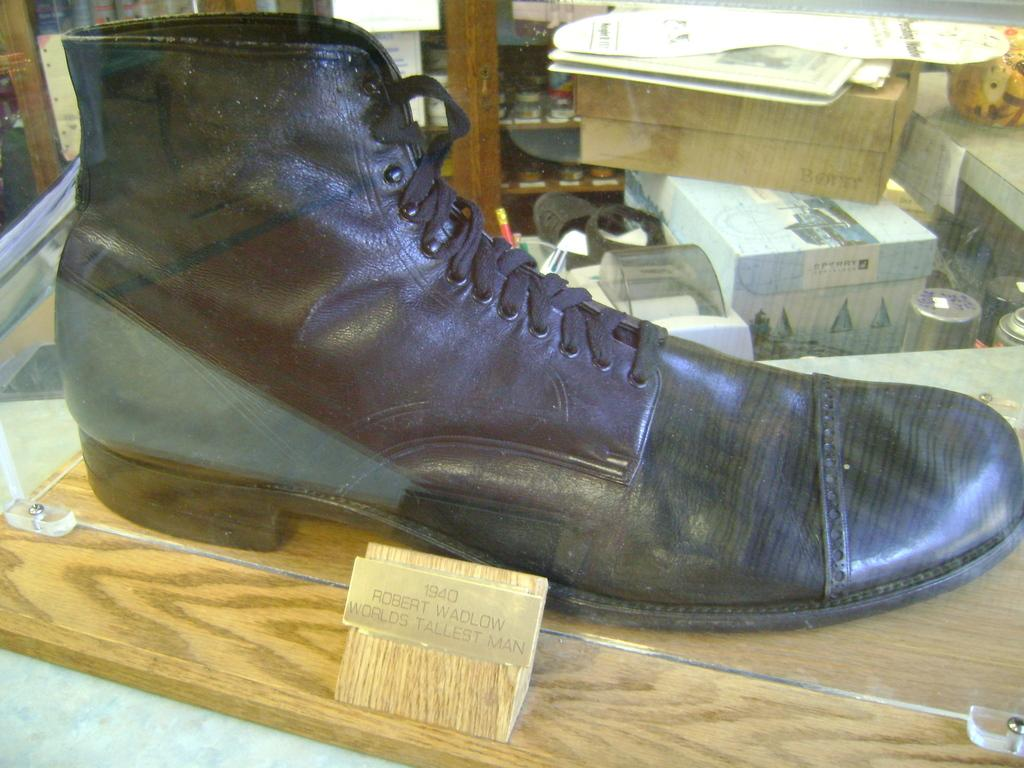What can be found in the image that contains written information? There is text in the image. What is placed on a wooden surface in the image? There is a shoe on a wooden surface. What can be seen in the background of the image? In the background, there are boxes, papers, and some unspecified objects. What scent is emitted by the text in the image? The text in the image does not emit any scent. What part of the shoe is visible in the image? The facts provided do not specify which part of the shoe is visible in the image. 